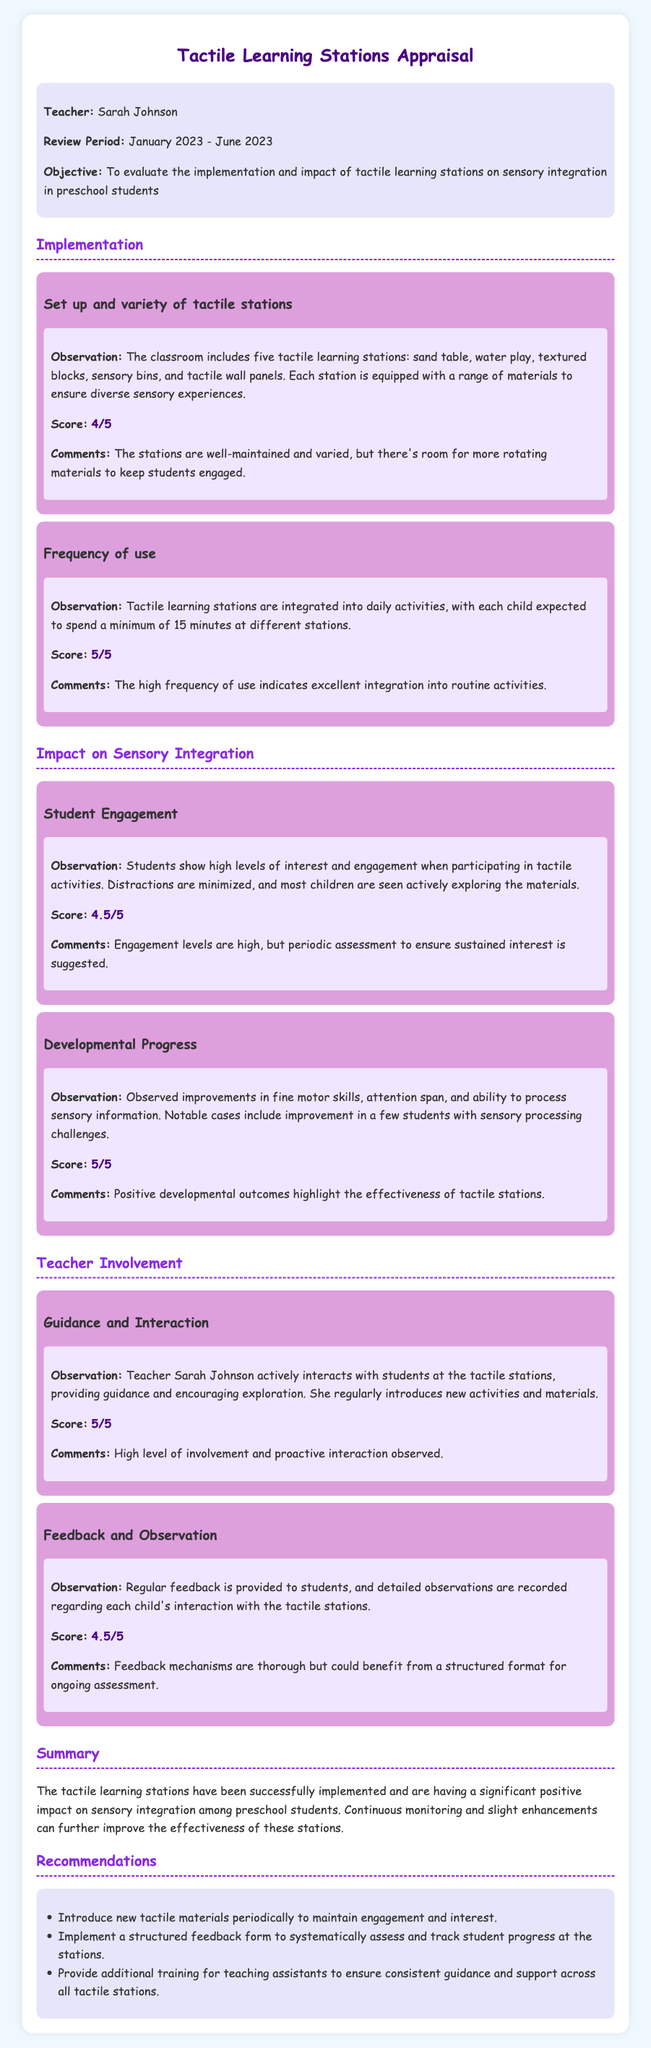What is the name of the teacher being evaluated? The teacher being evaluated is named Sarah Johnson, as mentioned in the information section of the document.
Answer: Sarah Johnson What is the review period for the appraisal? The review period is specified as January 2023 to June 2023 in the information section.
Answer: January 2023 - June 2023 How many tactile learning stations are mentioned? The document states that there are five tactile learning stations in the classroom.
Answer: Five What is the score for the frequency of use? The score provided for the frequency of use is clearly stated as 5 out of 5 in the respective section.
Answer: 5/5 What observation highlights students' engagement levels? The observation notes that students show high levels of interest and engagement when participating in tactile activities.
Answer: High levels of interest What improvement areas were noted for student developmental progress? The document mentions observed improvements in fine motor skills, attention span, and ability to process sensory information.
Answer: Fine motor skills, attention span, sensory processing What score did guidance and interaction receive? The guidance and interaction aspect received a score of 5 out of 5, indicated in its section.
Answer: 5/5 Which recommendation suggests a change in materials? The recommendation advises introducing new tactile materials periodically to maintain engagement and interest.
Answer: Introduce new tactile materials What does the document suggest regarding feedback mechanisms? The document notes that feedback mechanisms are thorough but could benefit from a structured format for ongoing assessment.
Answer: Structured format for ongoing assessment 